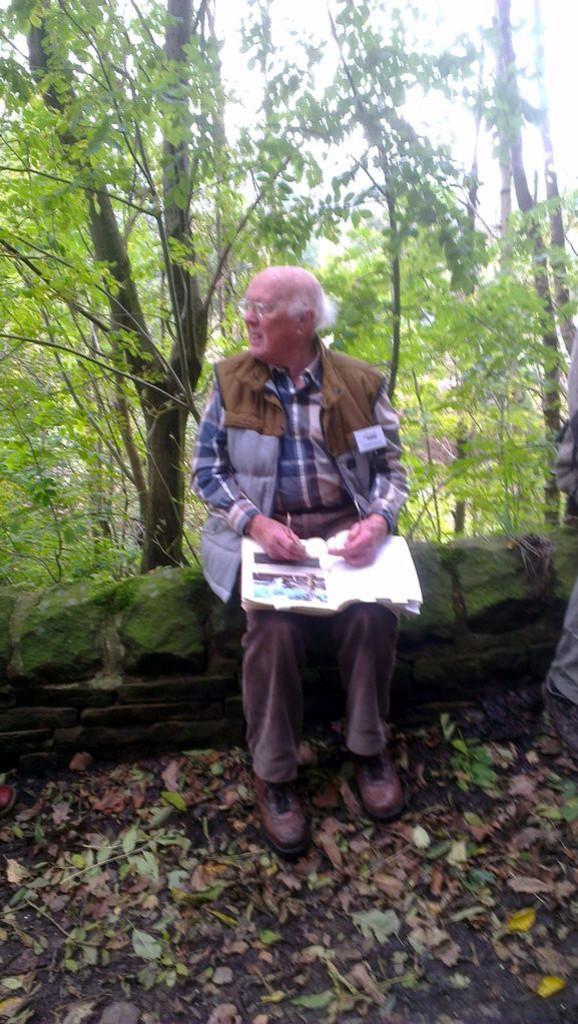Could you give a brief overview of what you see in this image? Here we can see a old man sitting on a platform and there is a book on his legs and he is holding an object in his hands. There are leaves on the ground. In the background there are trees and sky. 